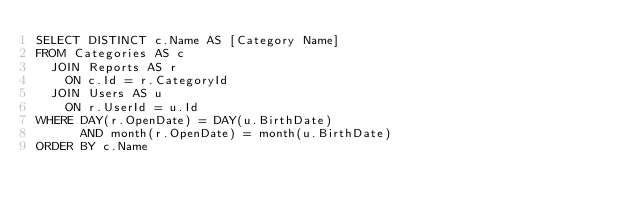<code> <loc_0><loc_0><loc_500><loc_500><_SQL_>SELECT DISTINCT c.Name AS [Category Name]
FROM Categories AS c
  JOIN Reports AS r
    ON c.Id = r.CategoryId
  JOIN Users AS u
    ON r.UserId = u.Id
WHERE DAY(r.OpenDate) = DAY(u.BirthDate)
      AND month(r.OpenDate) = month(u.BirthDate)
ORDER BY c.Name</code> 